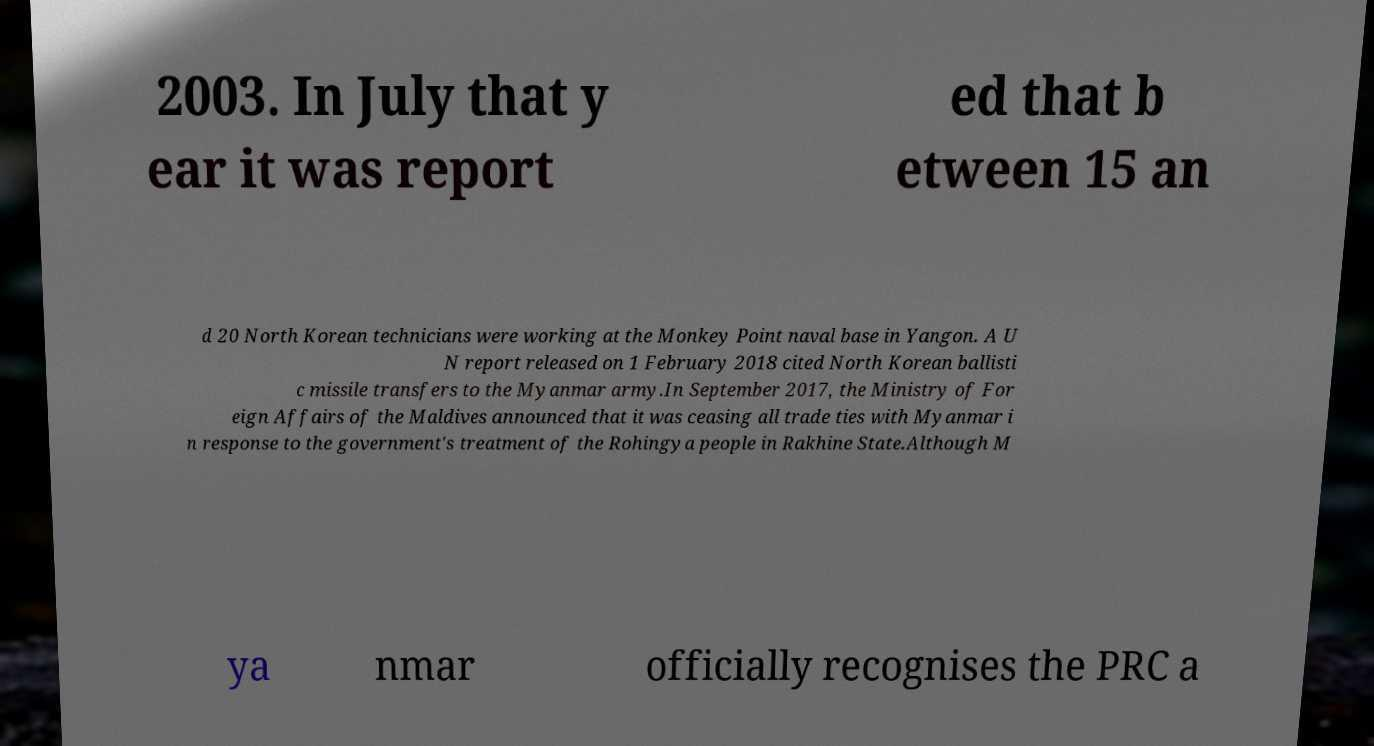Please identify and transcribe the text found in this image. 2003. In July that y ear it was report ed that b etween 15 an d 20 North Korean technicians were working at the Monkey Point naval base in Yangon. A U N report released on 1 February 2018 cited North Korean ballisti c missile transfers to the Myanmar army.In September 2017, the Ministry of For eign Affairs of the Maldives announced that it was ceasing all trade ties with Myanmar i n response to the government's treatment of the Rohingya people in Rakhine State.Although M ya nmar officially recognises the PRC a 